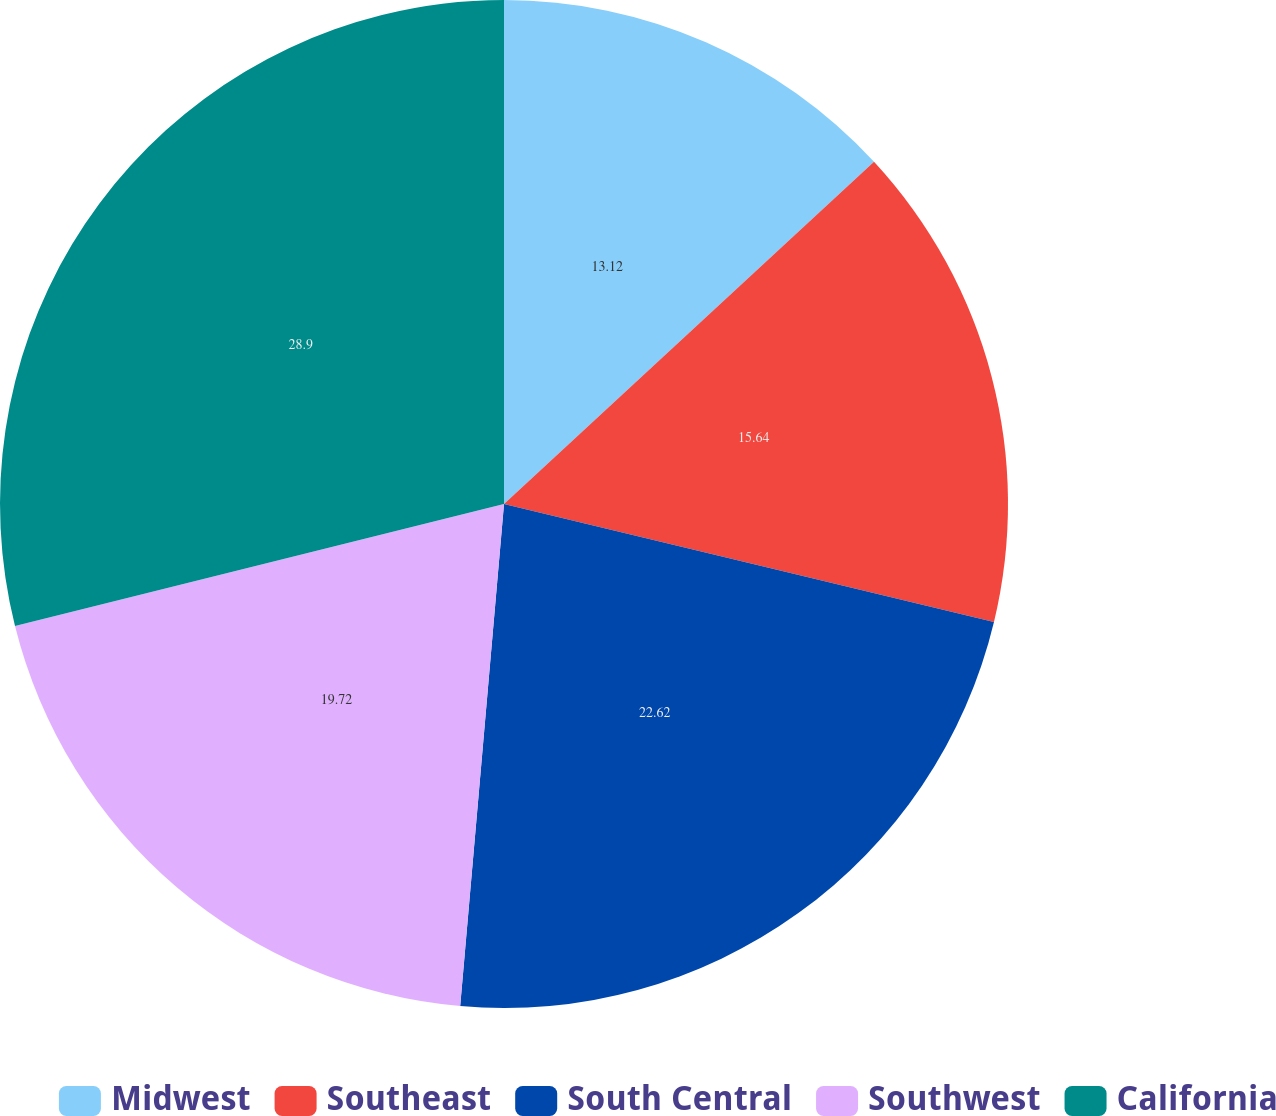<chart> <loc_0><loc_0><loc_500><loc_500><pie_chart><fcel>Midwest<fcel>Southeast<fcel>South Central<fcel>Southwest<fcel>California<nl><fcel>13.12%<fcel>15.64%<fcel>22.62%<fcel>19.72%<fcel>28.89%<nl></chart> 